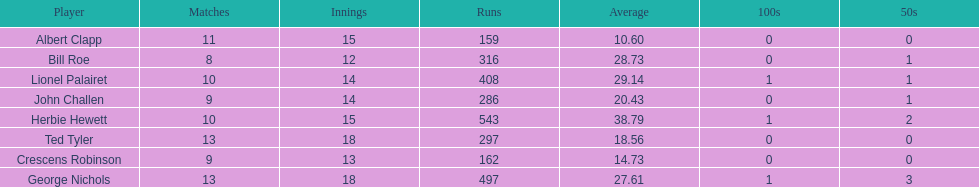How many more runs does john have than albert? 127. 